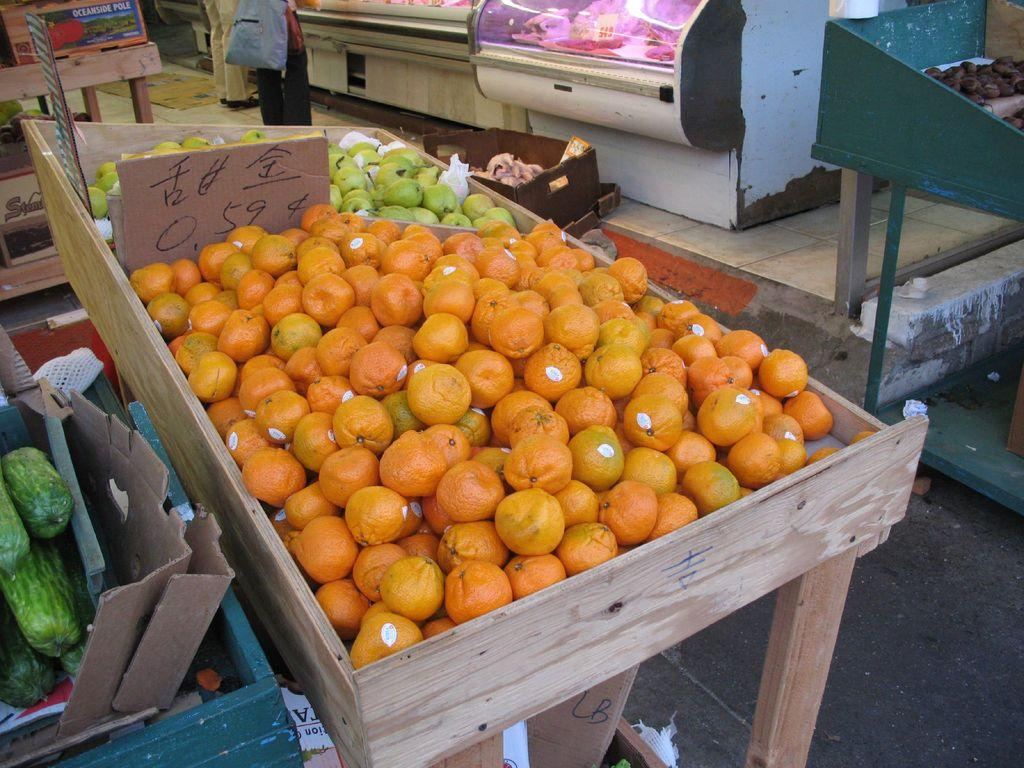What type of table is in the image? There is a wooden table in the image. What items can be seen on the table? There are many fruits and vegetables on the table. Is there any indication of the cost of the items in the image? Yes, there is a price tag visible in the image. What type of path is present in the image? There is a footpath in the image. Can you describe the person present in the image? A person wearing clothes is present in the image. How many children are playing on the beam in the image? There is no beam or children present in the image. What type of airplane can be seen flying in the image? There is no airplane visible in the image. 